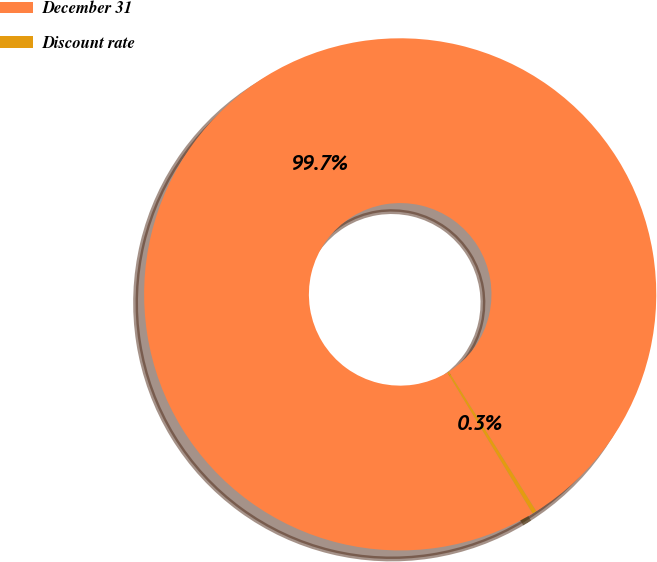Convert chart. <chart><loc_0><loc_0><loc_500><loc_500><pie_chart><fcel>December 31<fcel>Discount rate<nl><fcel>99.73%<fcel>0.27%<nl></chart> 